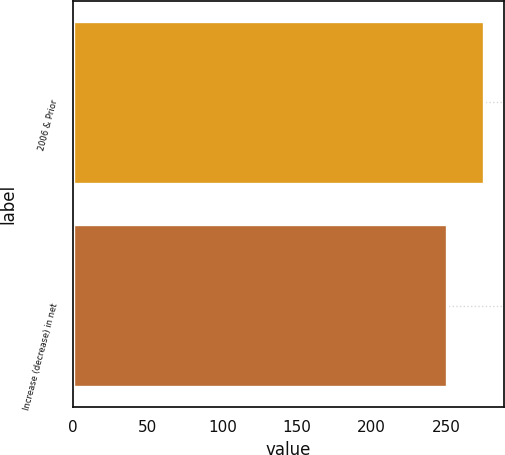Convert chart. <chart><loc_0><loc_0><loc_500><loc_500><bar_chart><fcel>2006 & Prior<fcel>Increase (decrease) in net<nl><fcel>275<fcel>250<nl></chart> 